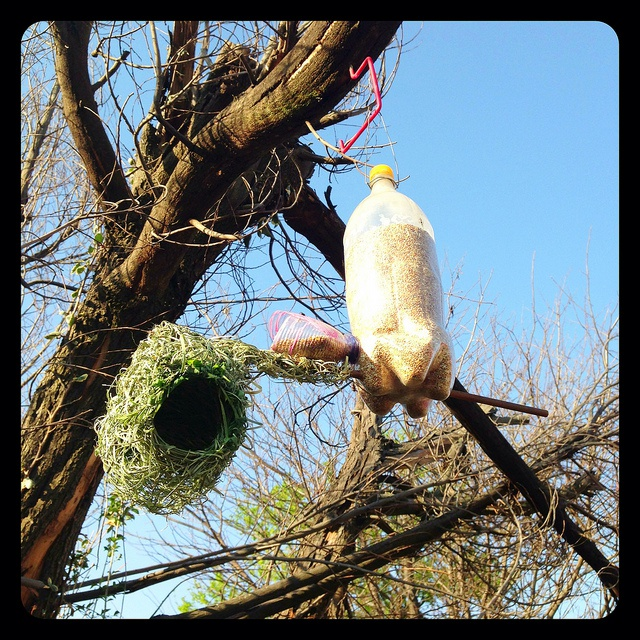Describe the objects in this image and their specific colors. I can see bottle in black, ivory, khaki, and darkgray tones and bird in black, lavender, maroon, brown, and lightpink tones in this image. 